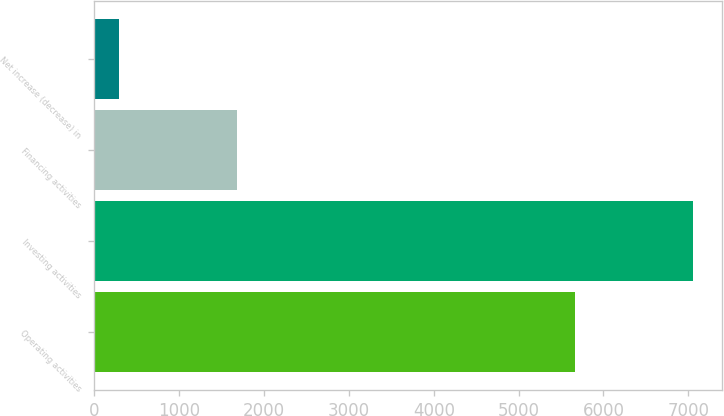Convert chart. <chart><loc_0><loc_0><loc_500><loc_500><bar_chart><fcel>Operating activities<fcel>Investing activities<fcel>Financing activities<fcel>Net increase (decrease) in<nl><fcel>5660<fcel>7051<fcel>1682<fcel>291<nl></chart> 